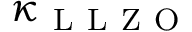Convert formula to latex. <formula><loc_0><loc_0><loc_500><loc_500>\kappa _ { L L Z O }</formula> 